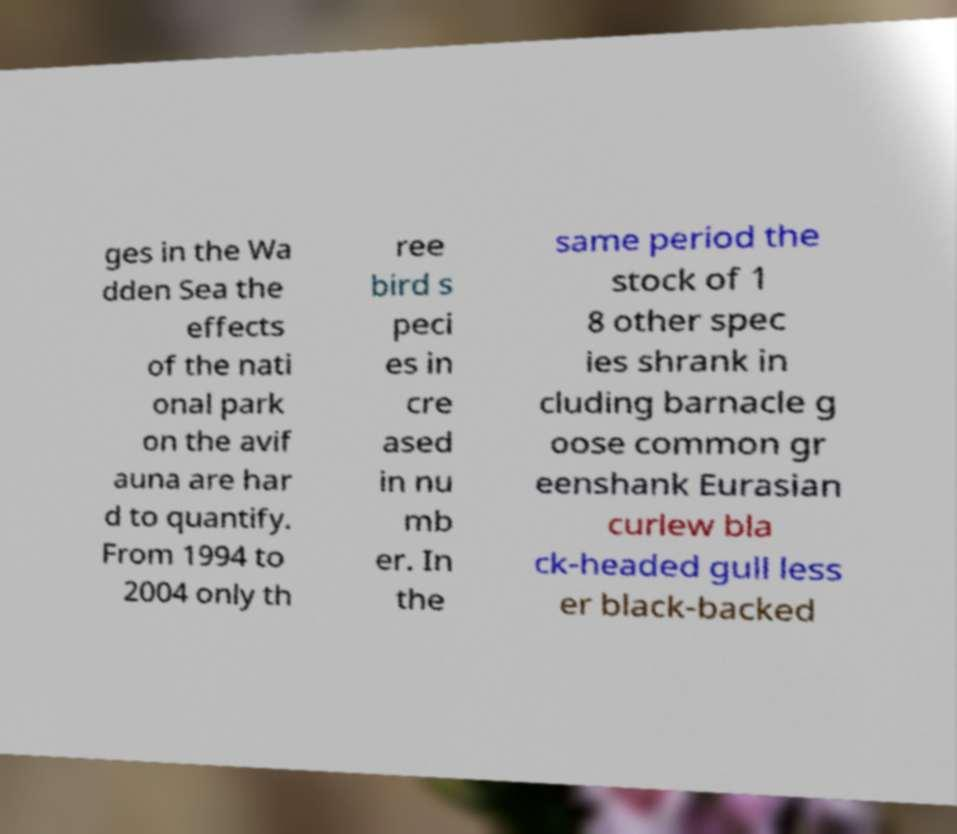Can you accurately transcribe the text from the provided image for me? ges in the Wa dden Sea the effects of the nati onal park on the avif auna are har d to quantify. From 1994 to 2004 only th ree bird s peci es in cre ased in nu mb er. In the same period the stock of 1 8 other spec ies shrank in cluding barnacle g oose common gr eenshank Eurasian curlew bla ck-headed gull less er black-backed 